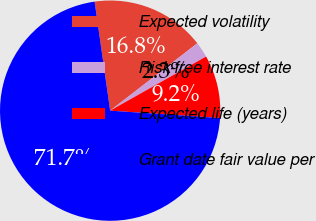Convert chart. <chart><loc_0><loc_0><loc_500><loc_500><pie_chart><fcel>Expected volatility<fcel>Risk-free interest rate<fcel>Expected life (years)<fcel>Grant date fair value per<nl><fcel>16.78%<fcel>2.3%<fcel>9.24%<fcel>71.68%<nl></chart> 